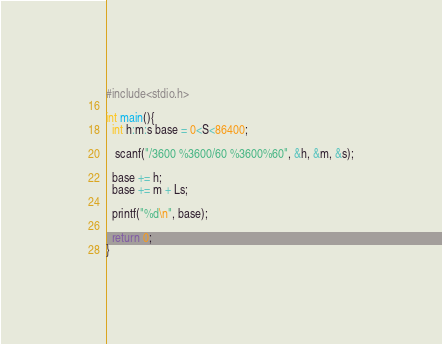Convert code to text. <code><loc_0><loc_0><loc_500><loc_500><_C++_>#include<stdio.h>

int main(){
  int h:m:s base = 0<S<86400;
  
   scanf("/3600 %3600/60 %3600%60", &h, &m, &s);

  base += h;
  base += m + Ls;

  printf("%d\n", base);

  return 0;
}
</code> 